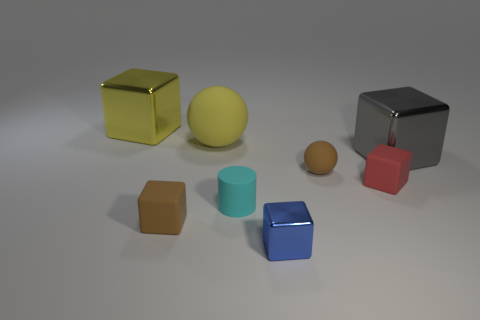Subtract all blue blocks. How many blocks are left? 4 Subtract all small brown matte cubes. How many cubes are left? 4 Subtract all purple blocks. Subtract all gray balls. How many blocks are left? 5 Add 2 large yellow rubber objects. How many objects exist? 10 Subtract all cylinders. How many objects are left? 7 Add 5 big yellow rubber spheres. How many big yellow rubber spheres exist? 6 Subtract 0 red balls. How many objects are left? 8 Subtract all big brown cylinders. Subtract all big gray objects. How many objects are left? 7 Add 6 red objects. How many red objects are left? 7 